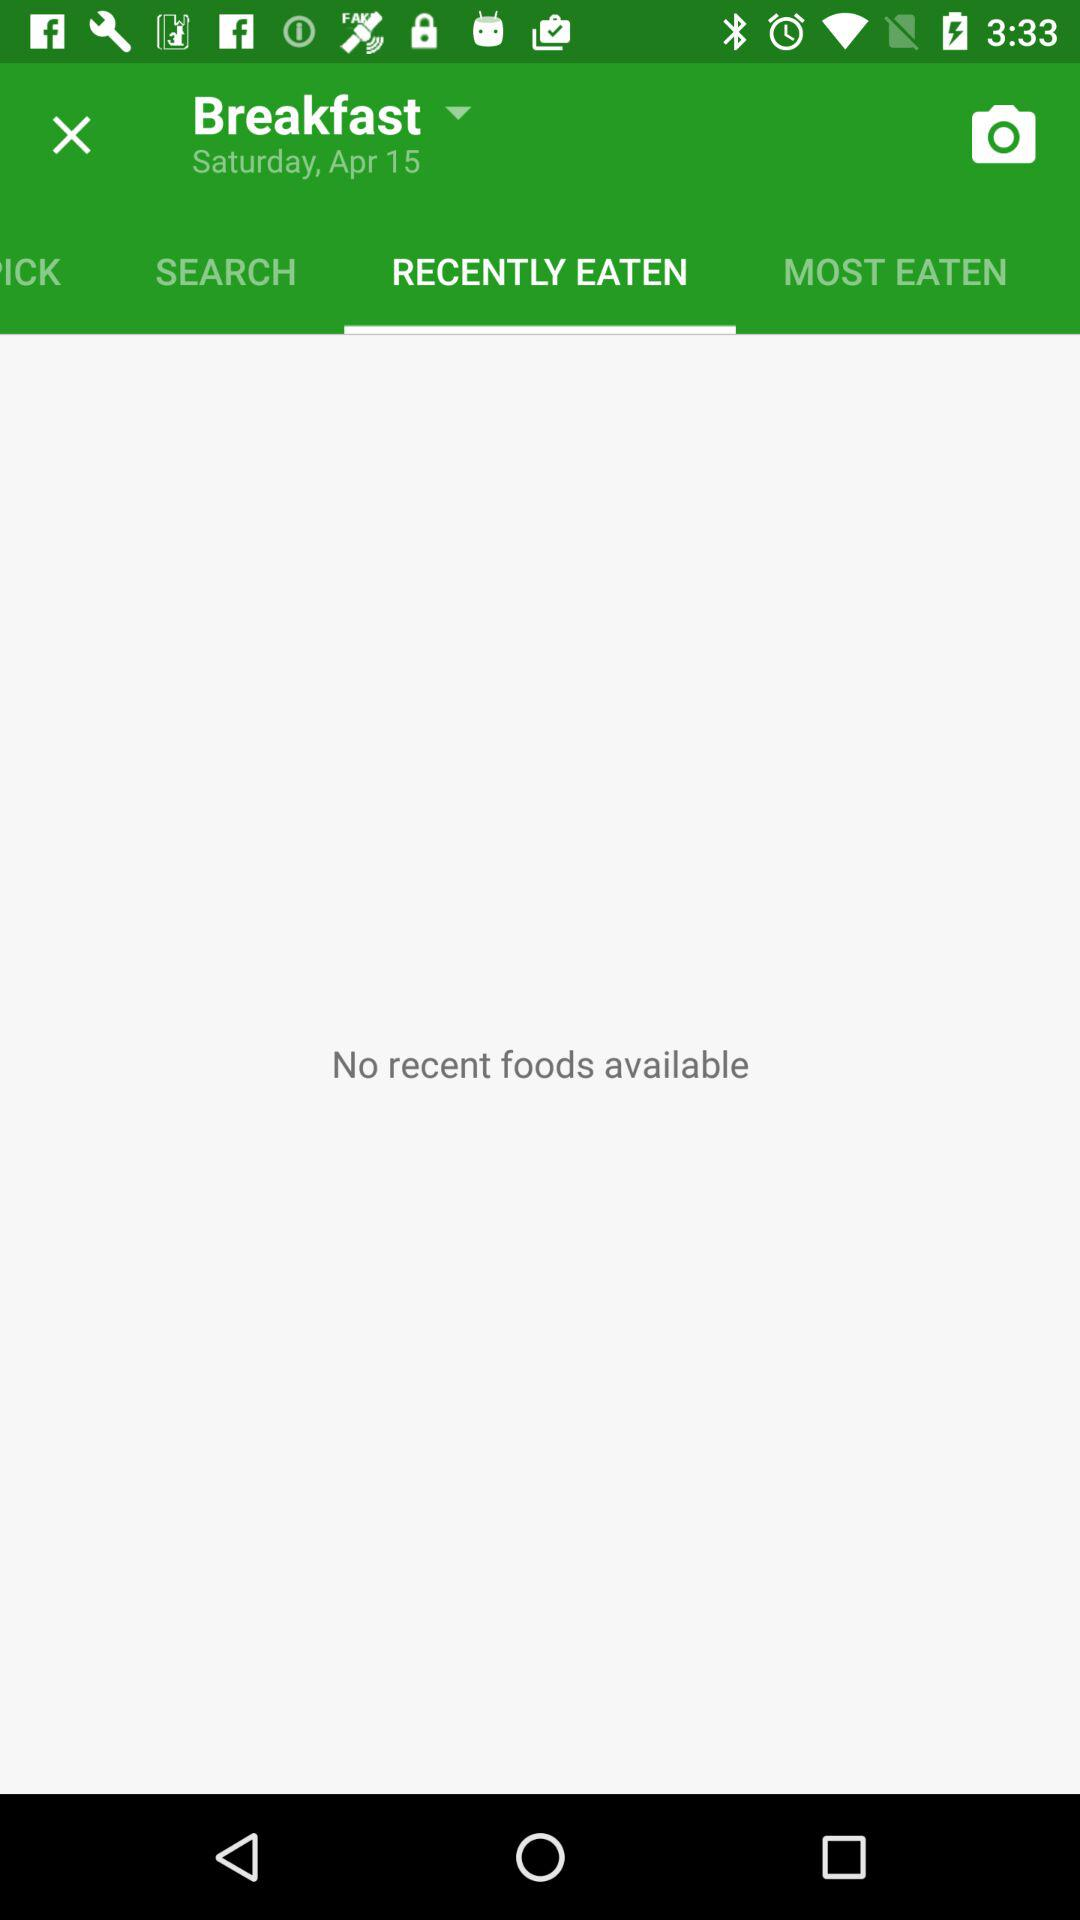Which tab is selected? The selected tab is "RECENTLY EATEN". 